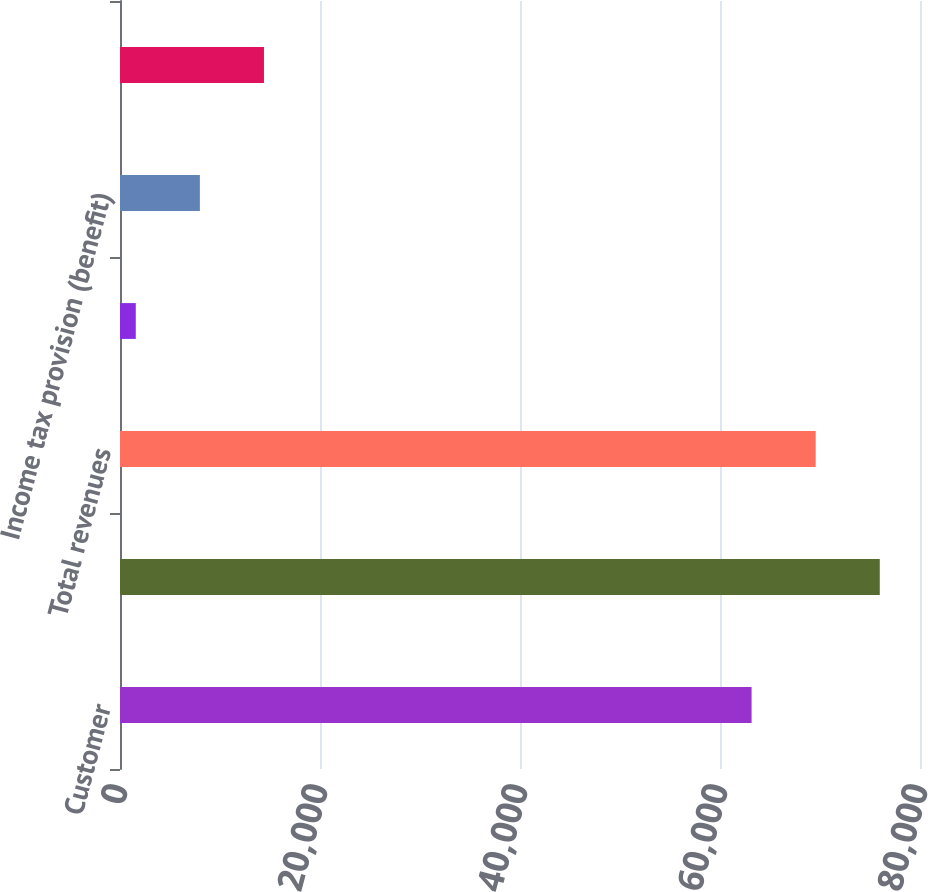Convert chart. <chart><loc_0><loc_0><loc_500><loc_500><bar_chart><fcel>Customer<fcel>Segment revenues<fcel>Total revenues<fcel>Depreciation depletion and<fcel>Income tax provision (benefit)<fcel>Capital expenditures (c)(d)<nl><fcel>63159<fcel>75977.2<fcel>69568.1<fcel>1578<fcel>7987.1<fcel>14396.2<nl></chart> 